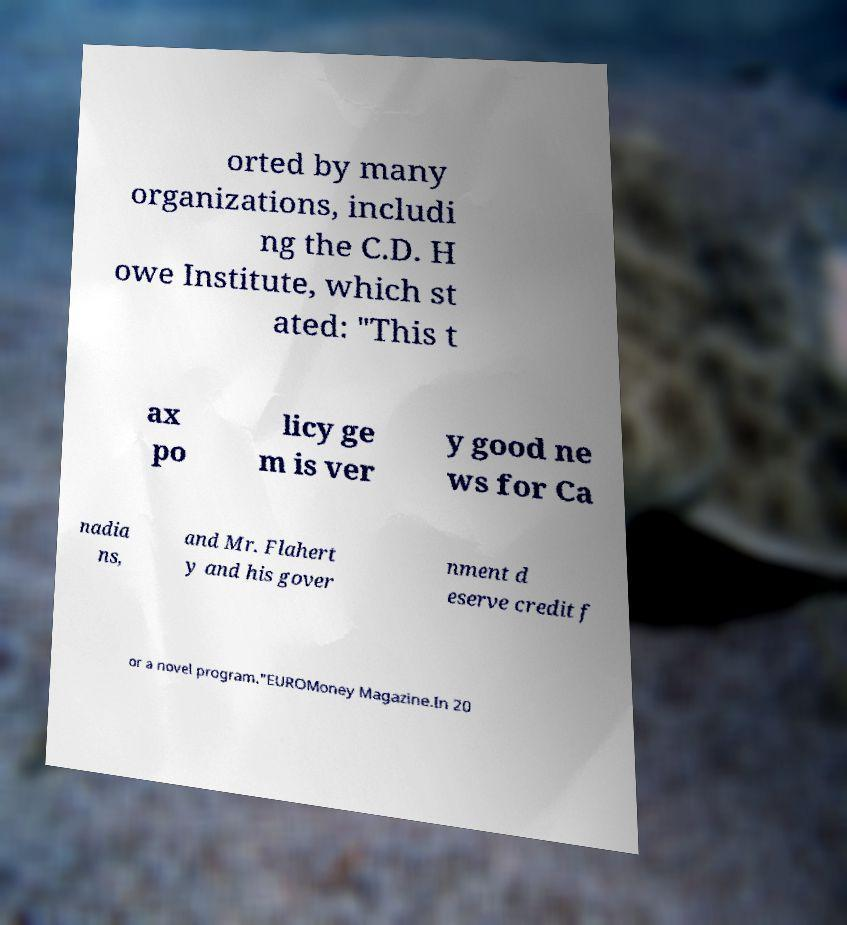Can you read and provide the text displayed in the image?This photo seems to have some interesting text. Can you extract and type it out for me? orted by many organizations, includi ng the C.D. H owe Institute, which st ated: "This t ax po licy ge m is ver y good ne ws for Ca nadia ns, and Mr. Flahert y and his gover nment d eserve credit f or a novel program."EUROMoney Magazine.In 20 